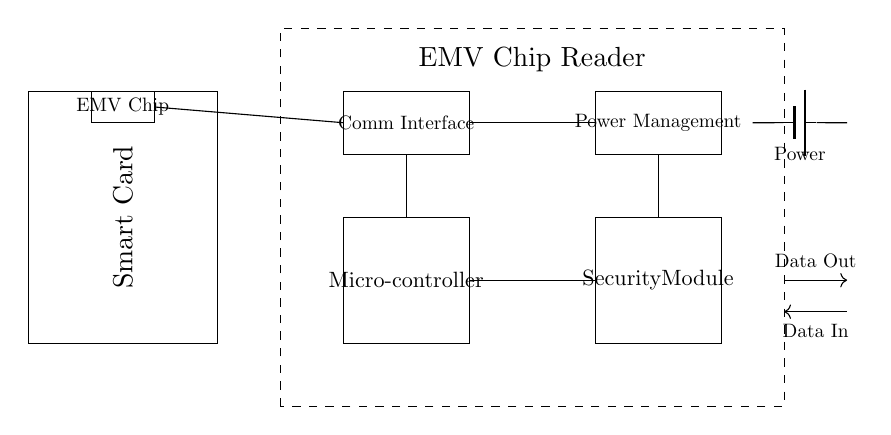What is the main purpose of the EMV chip reader? The primary purpose of the EMV chip reader is to facilitate secure smart card transactions by reading data from the EMV chip on the card.
Answer: secure transactions How many main components are shown in the circuit diagram? The circuit diagram features five main components: Smart Card, EMV Chip Reader, Microcontroller, Power Management, and Security Module.
Answer: five What type of module is used for data protection in this circuit? The module designated for data protection in this circuit is labeled as the Security Module, highlighting its role in managing the security of transactions.
Answer: Security Module How does power supply connect to the circuit? The power supply connects to the Power Management component via a battery, supplying the necessary voltage to the circuit.
Answer: battery Which component handles communication in the circuit? The component specifically responsible for handling communication is the Communication Interface, which links the reader's data lines to the rest of the circuit.
Answer: Communication Interface What kind of power source is depicted in the circuit? The depicted power source in the circuit is a battery, characterized by its symbolic representation, indicating it supplies the Reader's components with energy.
Answer: battery What is the function of the microcontroller in this setup? The microcontroller's function in this setup is to process data from the smart card, manage interactions with the Security Module, and control the overall operation of the EMV chip reader during transactions.
Answer: data processing 